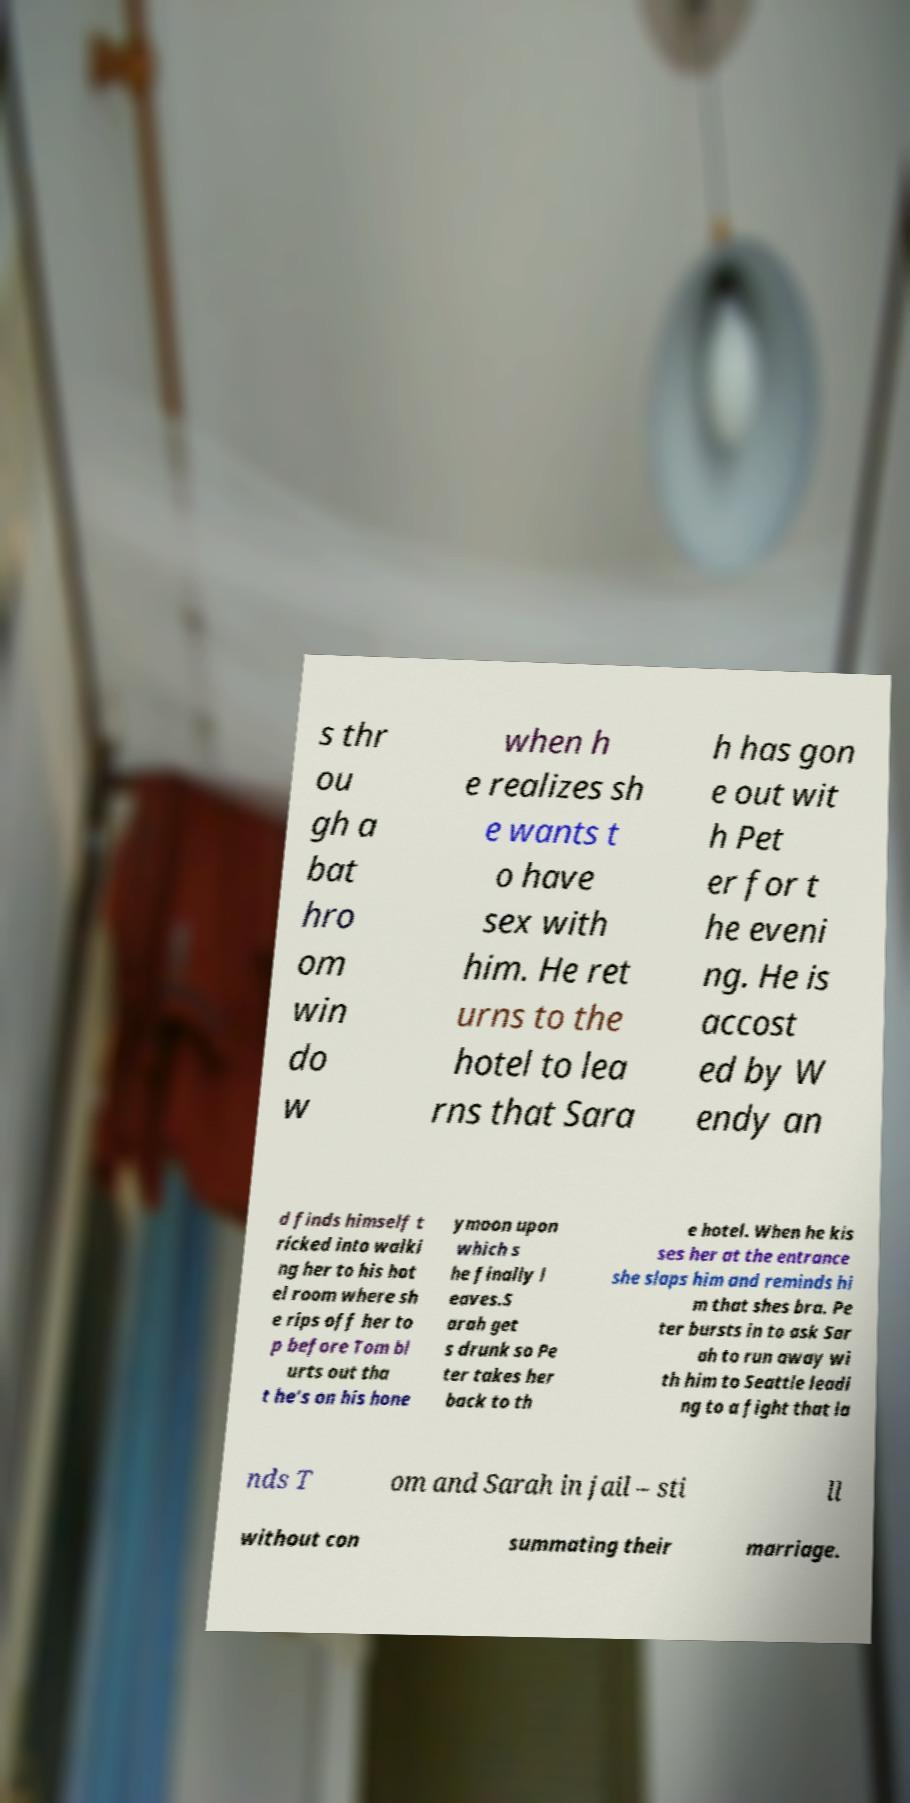I need the written content from this picture converted into text. Can you do that? s thr ou gh a bat hro om win do w when h e realizes sh e wants t o have sex with him. He ret urns to the hotel to lea rns that Sara h has gon e out wit h Pet er for t he eveni ng. He is accost ed by W endy an d finds himself t ricked into walki ng her to his hot el room where sh e rips off her to p before Tom bl urts out tha t he's on his hone ymoon upon which s he finally l eaves.S arah get s drunk so Pe ter takes her back to th e hotel. When he kis ses her at the entrance she slaps him and reminds hi m that shes bra. Pe ter bursts in to ask Sar ah to run away wi th him to Seattle leadi ng to a fight that la nds T om and Sarah in jail – sti ll without con summating their marriage. 